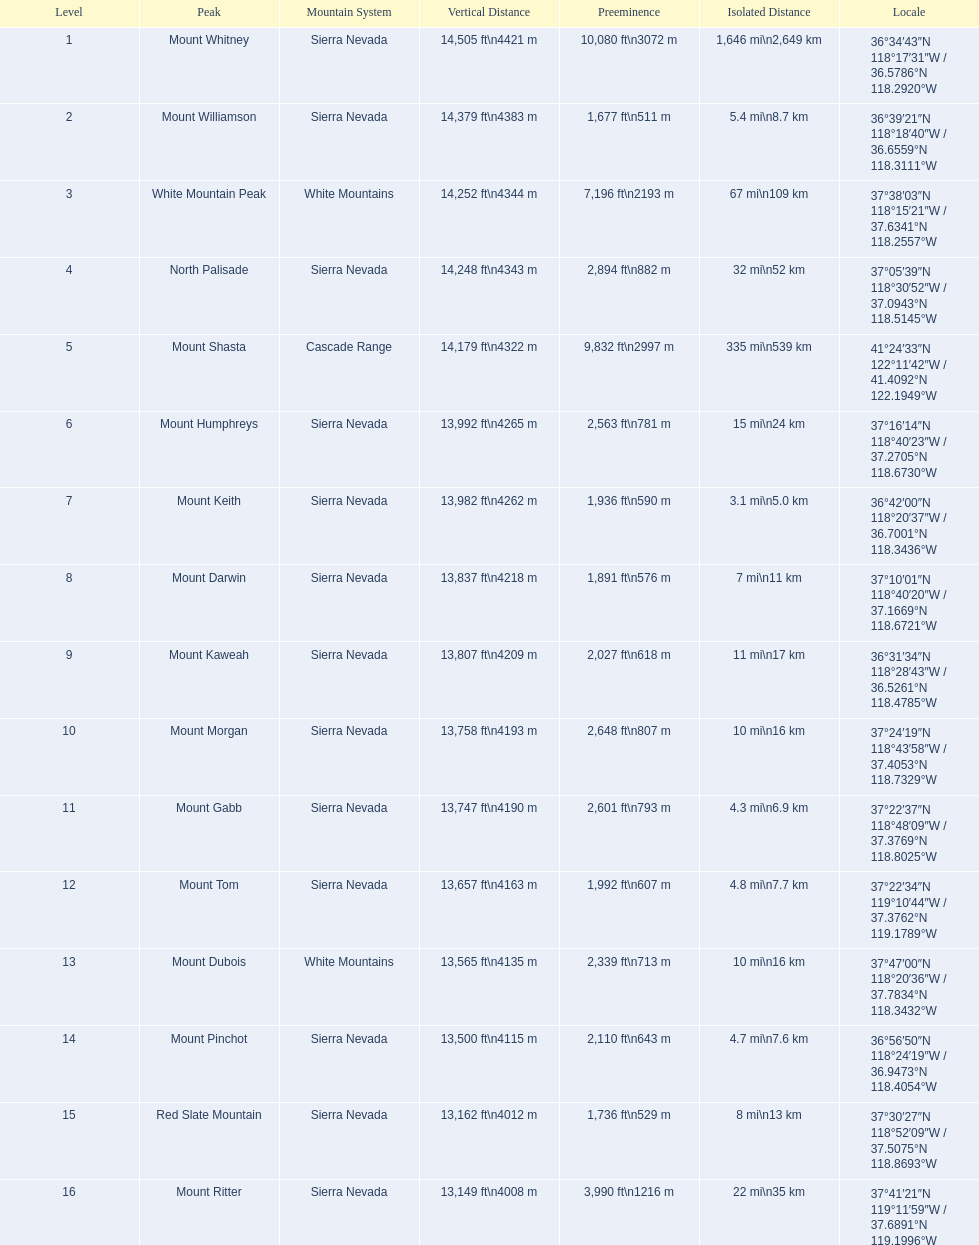What are the heights of the peaks? 14,505 ft\n4421 m, 14,379 ft\n4383 m, 14,252 ft\n4344 m, 14,248 ft\n4343 m, 14,179 ft\n4322 m, 13,992 ft\n4265 m, 13,982 ft\n4262 m, 13,837 ft\n4218 m, 13,807 ft\n4209 m, 13,758 ft\n4193 m, 13,747 ft\n4190 m, 13,657 ft\n4163 m, 13,565 ft\n4135 m, 13,500 ft\n4115 m, 13,162 ft\n4012 m, 13,149 ft\n4008 m. Which of these heights is tallest? 14,505 ft\n4421 m. What peak is 14,505 feet? Mount Whitney. 